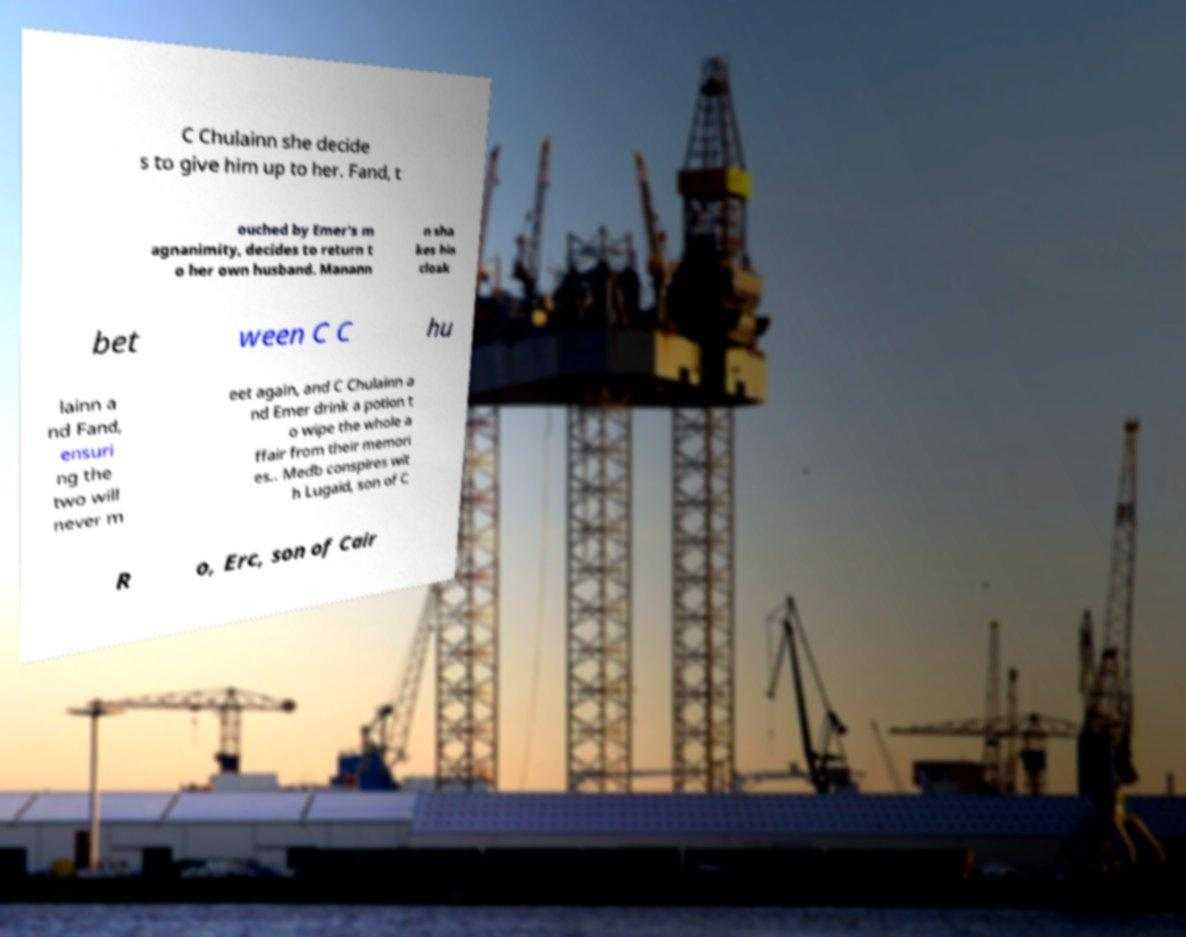I need the written content from this picture converted into text. Can you do that? C Chulainn she decide s to give him up to her. Fand, t ouched by Emer's m agnanimity, decides to return t o her own husband. Manann n sha kes his cloak bet ween C C hu lainn a nd Fand, ensuri ng the two will never m eet again, and C Chulainn a nd Emer drink a potion t o wipe the whole a ffair from their memori es.. Medb conspires wit h Lugaid, son of C R o, Erc, son of Cair 